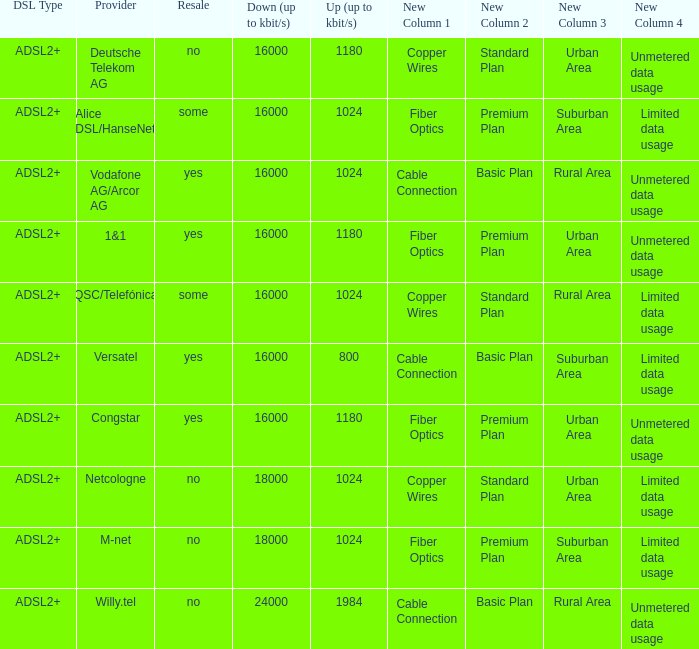Who are all of the telecom providers for which the upload rate is 1024 kbits and the resale category is yes? Vodafone AG/Arcor AG. 